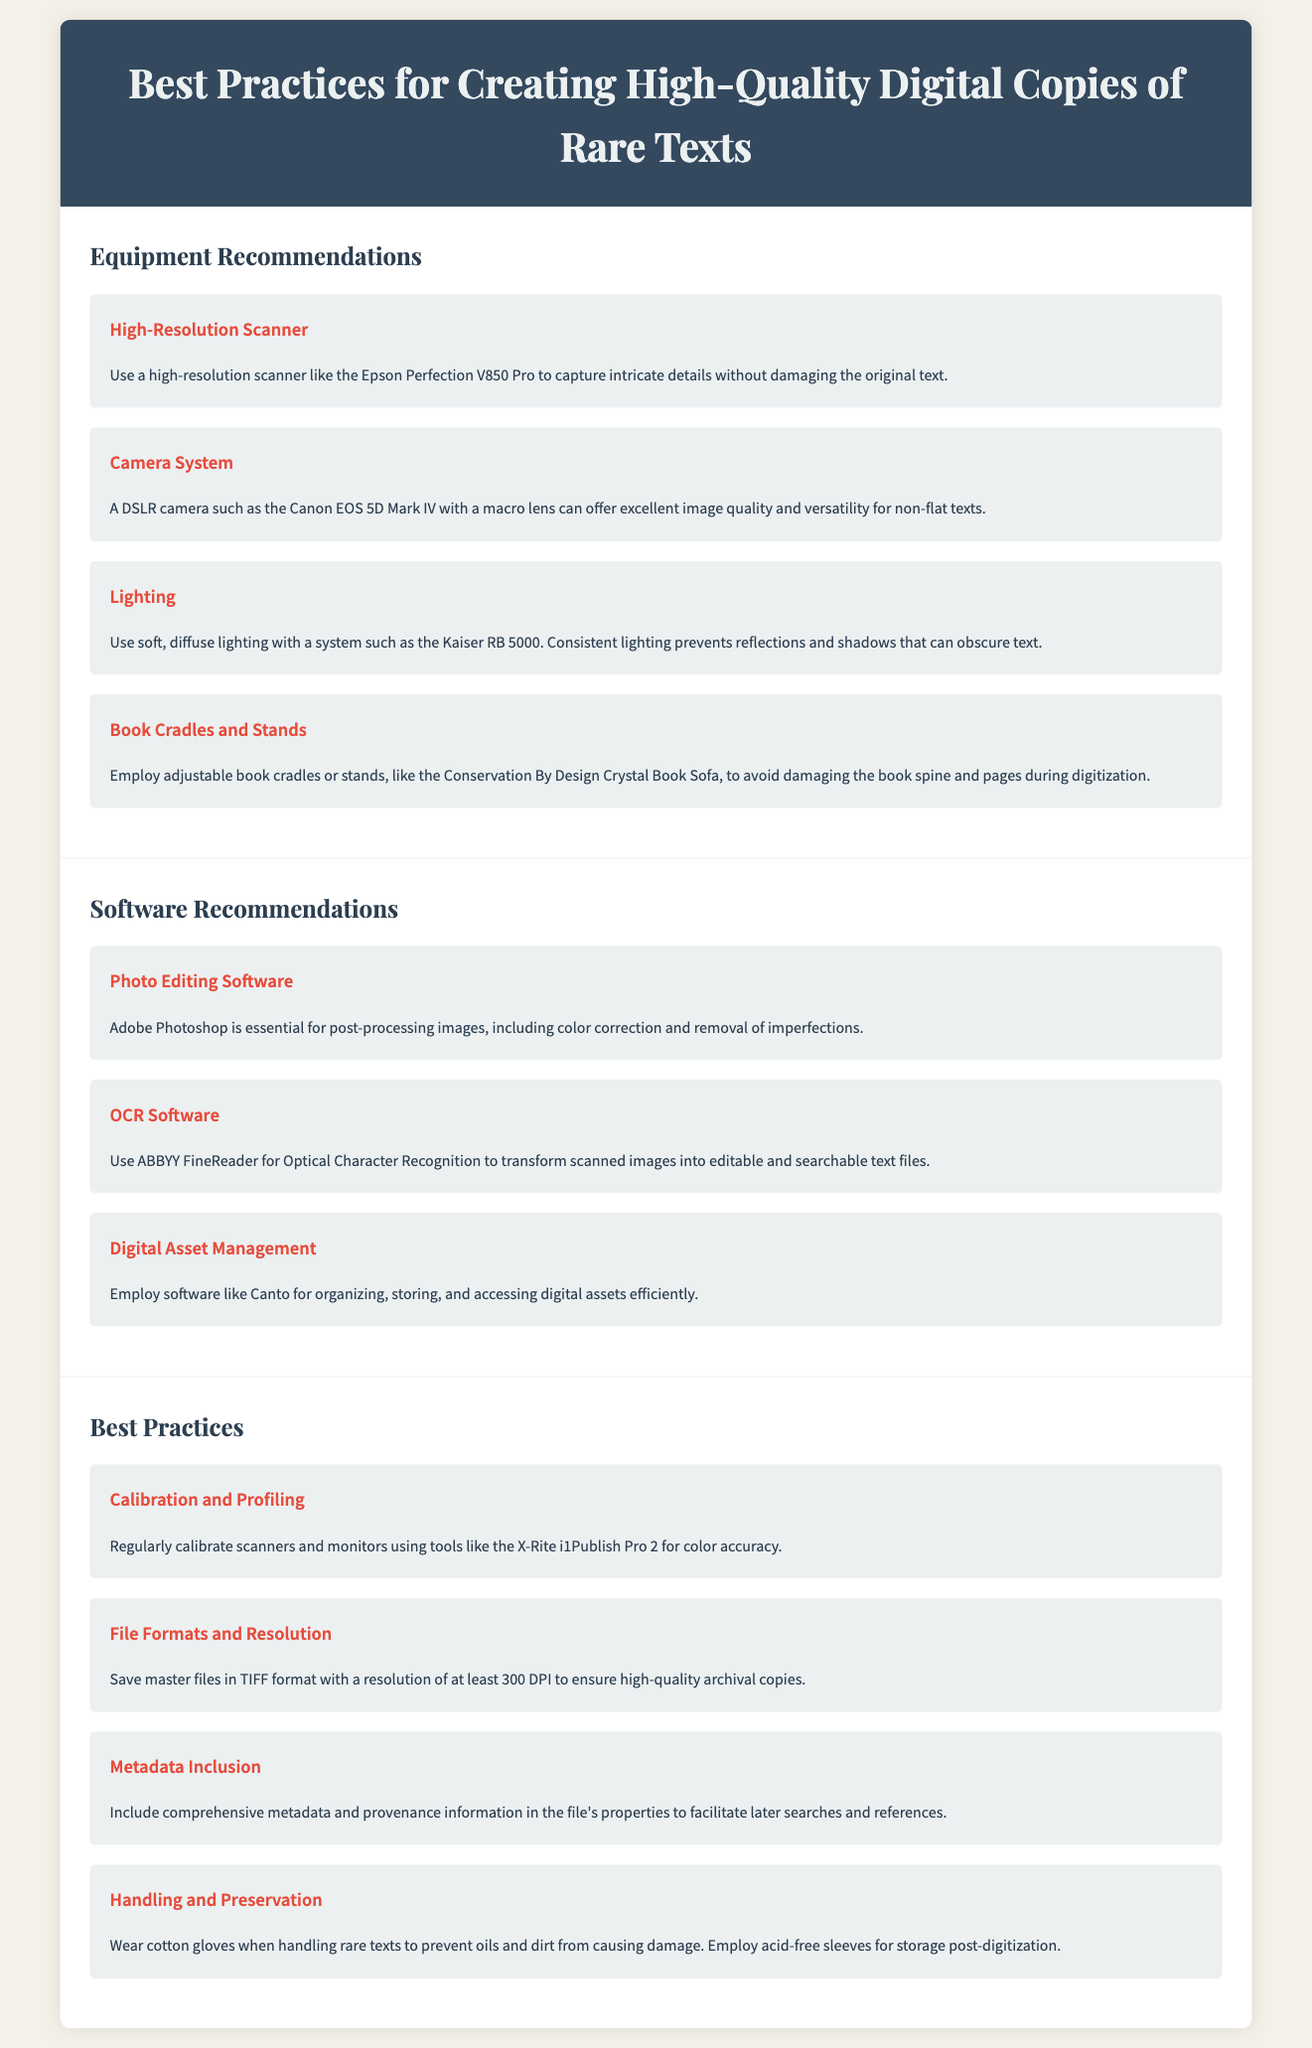What is a recommended high-resolution scanner? The document lists the Epson Perfection V850 Pro as a recommended high-resolution scanner to capture intricate details.
Answer: Epson Perfection V850 Pro Which software is essential for post-processing images? Adobe Photoshop is mentioned in the document as essential for post-processing images, including color correction.
Answer: Adobe Photoshop What file format should master files be saved in? The document states that master files should be saved in TIFF format to ensure high-quality archival copies.
Answer: TIFF What lighting system is suggested to prevent reflections? The Kaiser RB 5000 is recommended for its soft, diffuse lighting to prevent reflections and shadows.
Answer: Kaiser RB 5000 How often should scanners and monitors be calibrated? The document implies that calibration should be done regularly, though it does not specify a frequency.
Answer: Regularly What is the purpose of ABBYY FineReader? The document explains that ABBYY FineReader is used for Optical Character Recognition to transform scanned images into editable text.
Answer: Optical Character Recognition What type of gloves should be worn when handling rare texts? Cotton gloves are recommended to prevent oils and dirt from causing damage to rare texts during handling.
Answer: Cotton gloves What is one benefit of including metadata in digital files? Including comprehensive metadata in file properties facilitates later searches and references, as stated in the document.
Answer: Facilitate later searches Name one piece of equipment recommended to avoid damaging book spines. The Conservation By Design Crystal Book Sofa is suggested to avoid damaging the book spine during digitization.
Answer: Conservation By Design Crystal Book Sofa 